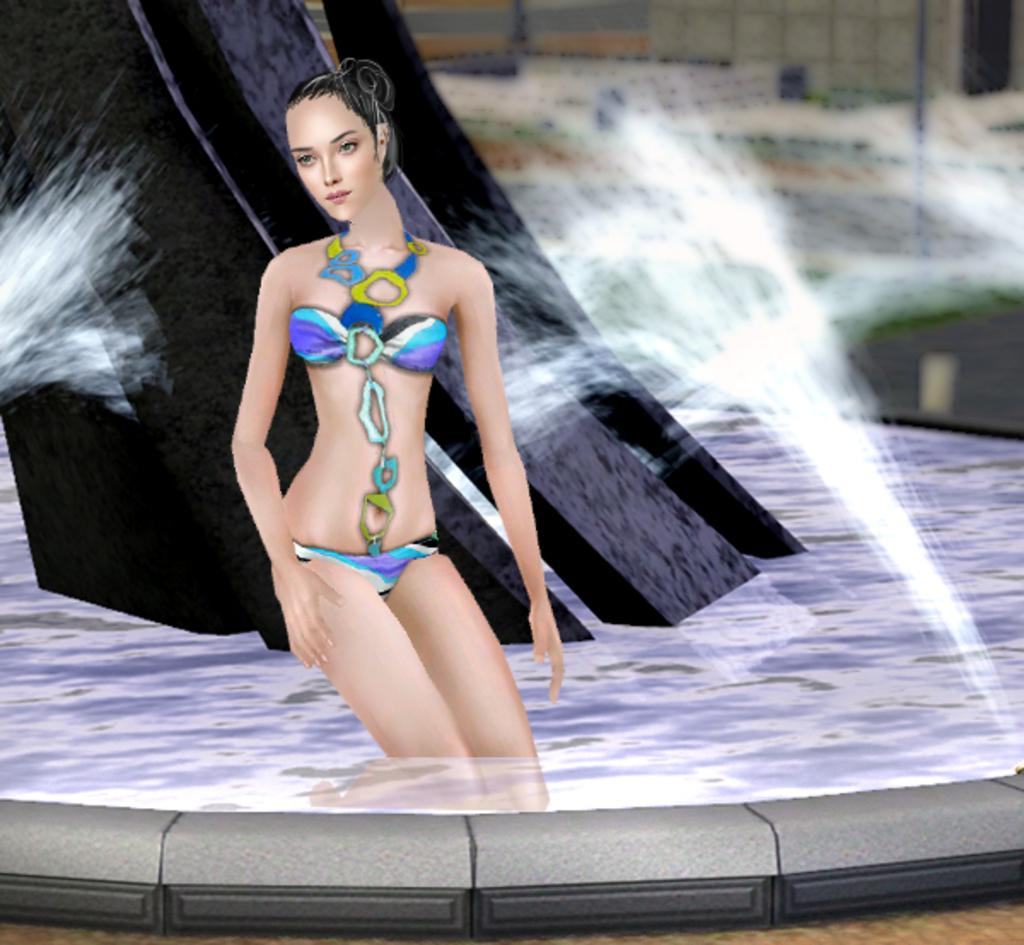What is the main subject of the image? There is a painting in the image. What is depicted in the painting? The painting contains a building and a woman standing in water. What type of pump can be seen in the painting? There is no pump present in the painting; it features a building and a woman standing in water. 